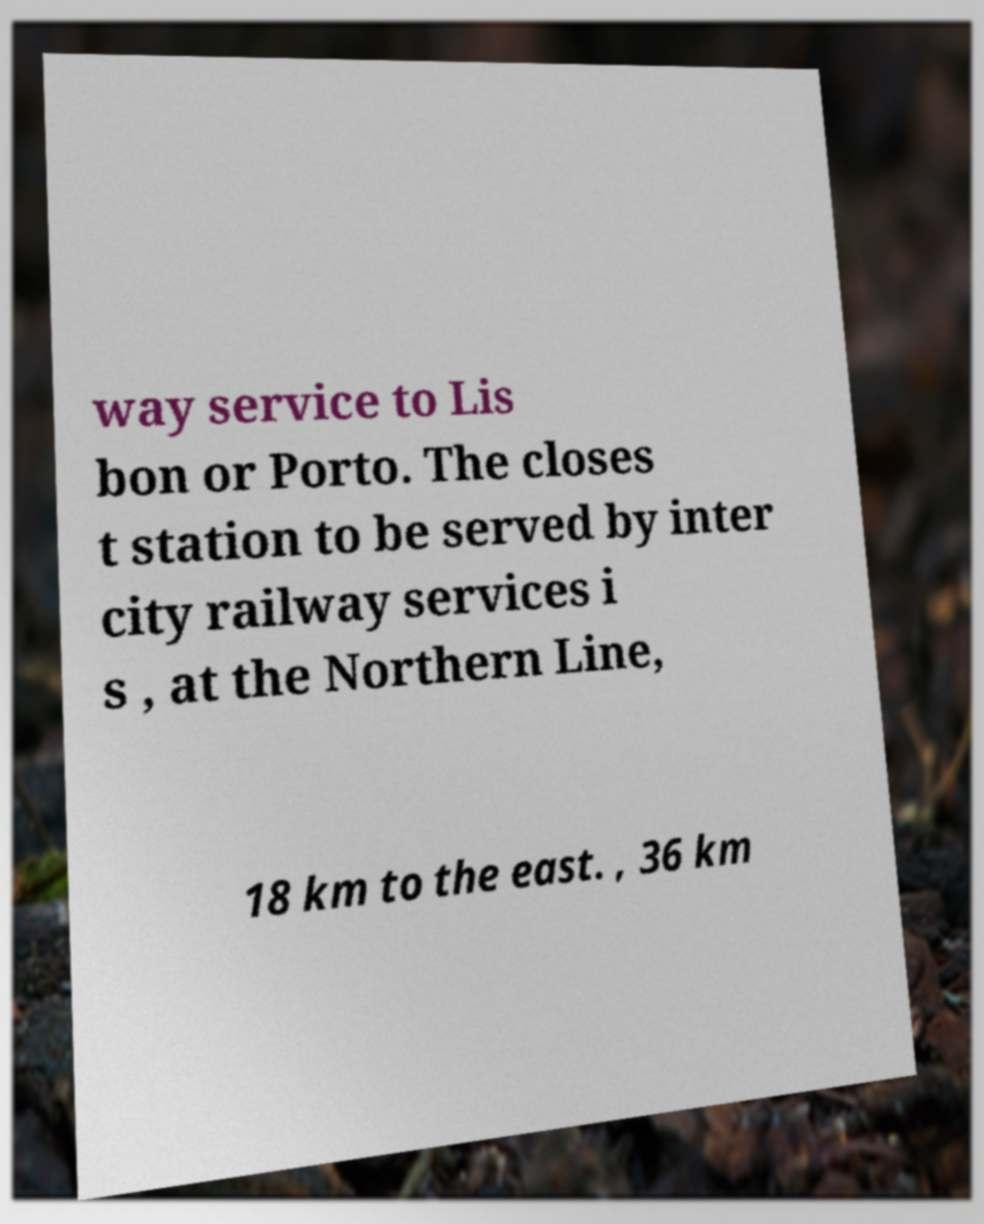Could you assist in decoding the text presented in this image and type it out clearly? way service to Lis bon or Porto. The closes t station to be served by inter city railway services i s , at the Northern Line, 18 km to the east. , 36 km 